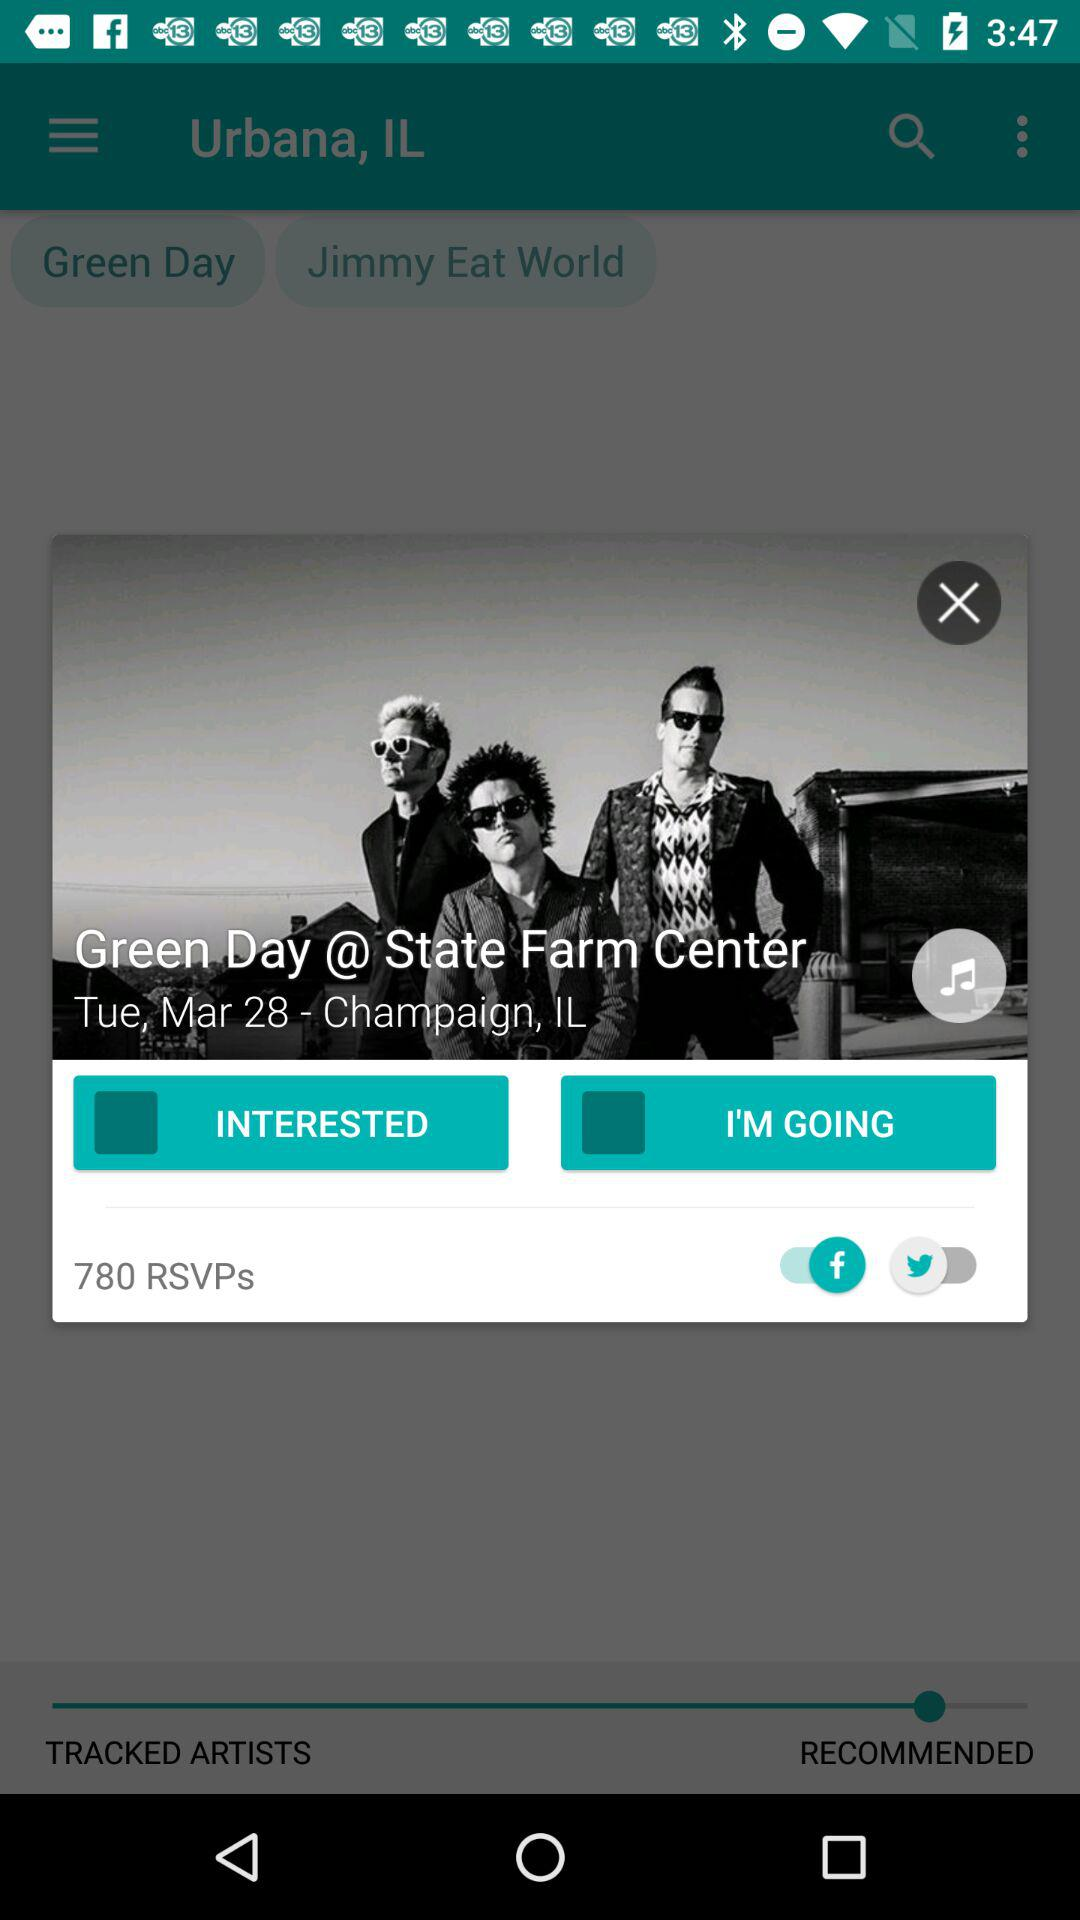What is the day? The day is Tuesday. 